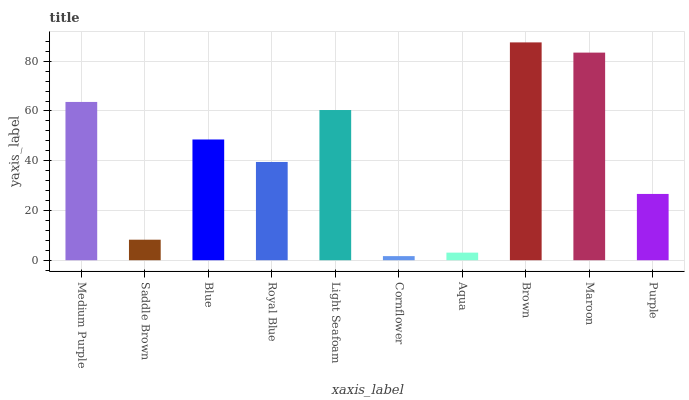Is Cornflower the minimum?
Answer yes or no. Yes. Is Brown the maximum?
Answer yes or no. Yes. Is Saddle Brown the minimum?
Answer yes or no. No. Is Saddle Brown the maximum?
Answer yes or no. No. Is Medium Purple greater than Saddle Brown?
Answer yes or no. Yes. Is Saddle Brown less than Medium Purple?
Answer yes or no. Yes. Is Saddle Brown greater than Medium Purple?
Answer yes or no. No. Is Medium Purple less than Saddle Brown?
Answer yes or no. No. Is Blue the high median?
Answer yes or no. Yes. Is Royal Blue the low median?
Answer yes or no. Yes. Is Brown the high median?
Answer yes or no. No. Is Brown the low median?
Answer yes or no. No. 